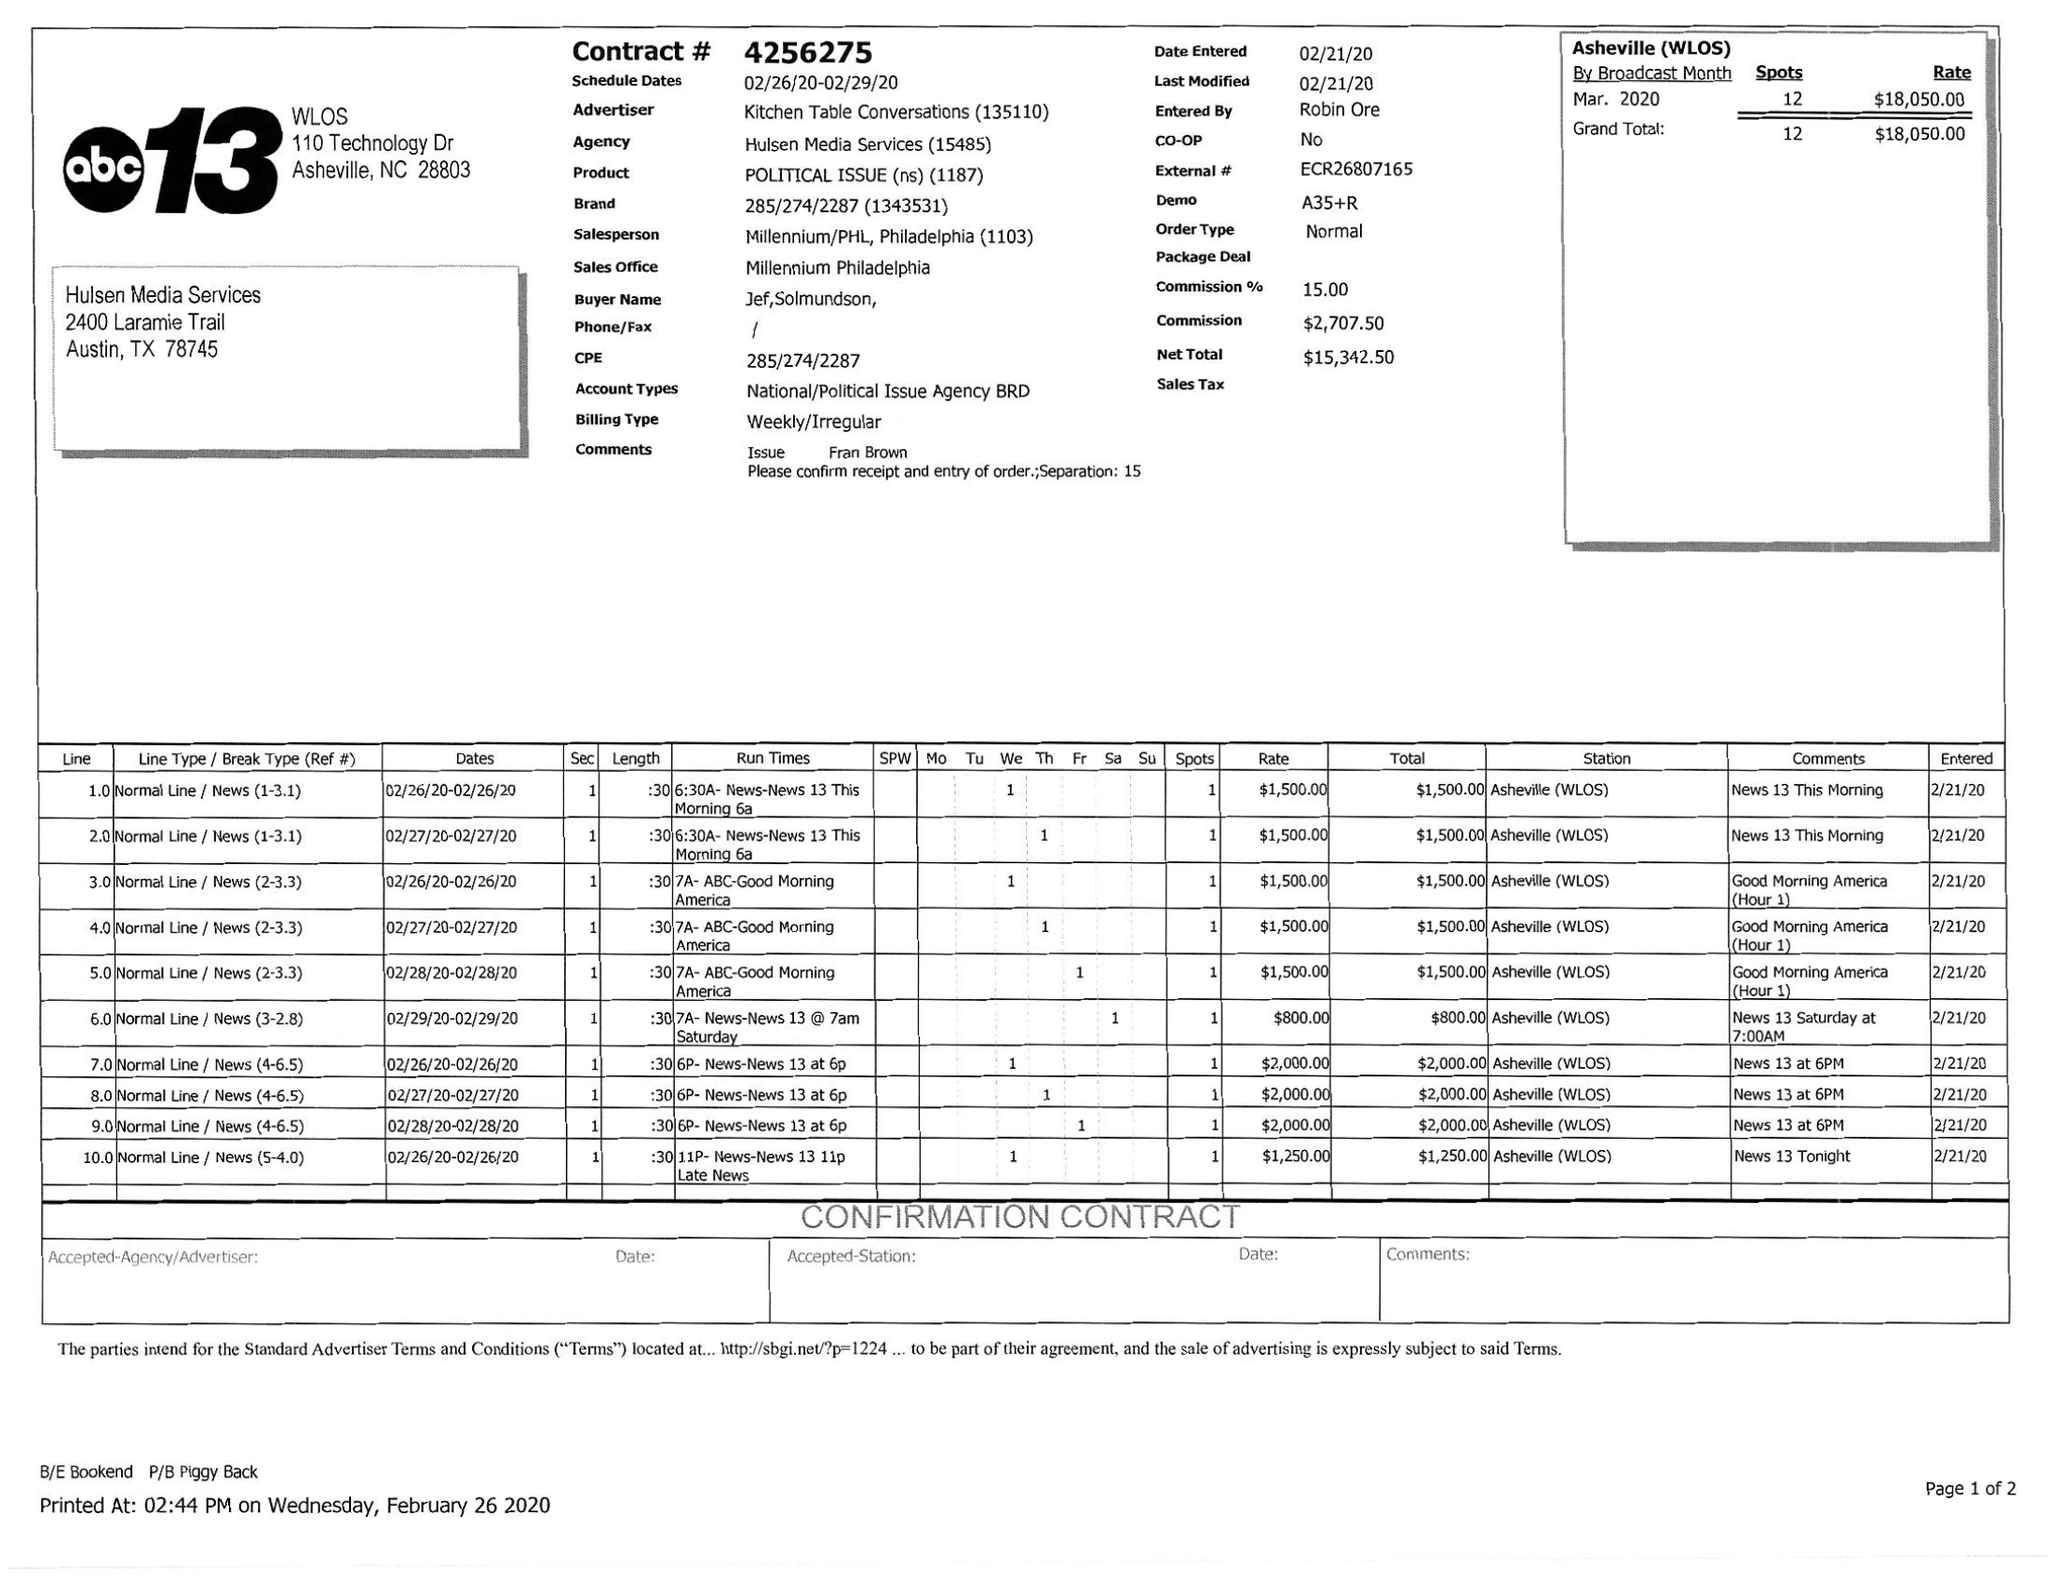What is the value for the contract_num?
Answer the question using a single word or phrase. 4256275 